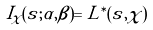<formula> <loc_0><loc_0><loc_500><loc_500>I _ { \chi } ( s ; \alpha , \beta ) = L ^ { \ast } ( s , \chi )</formula> 